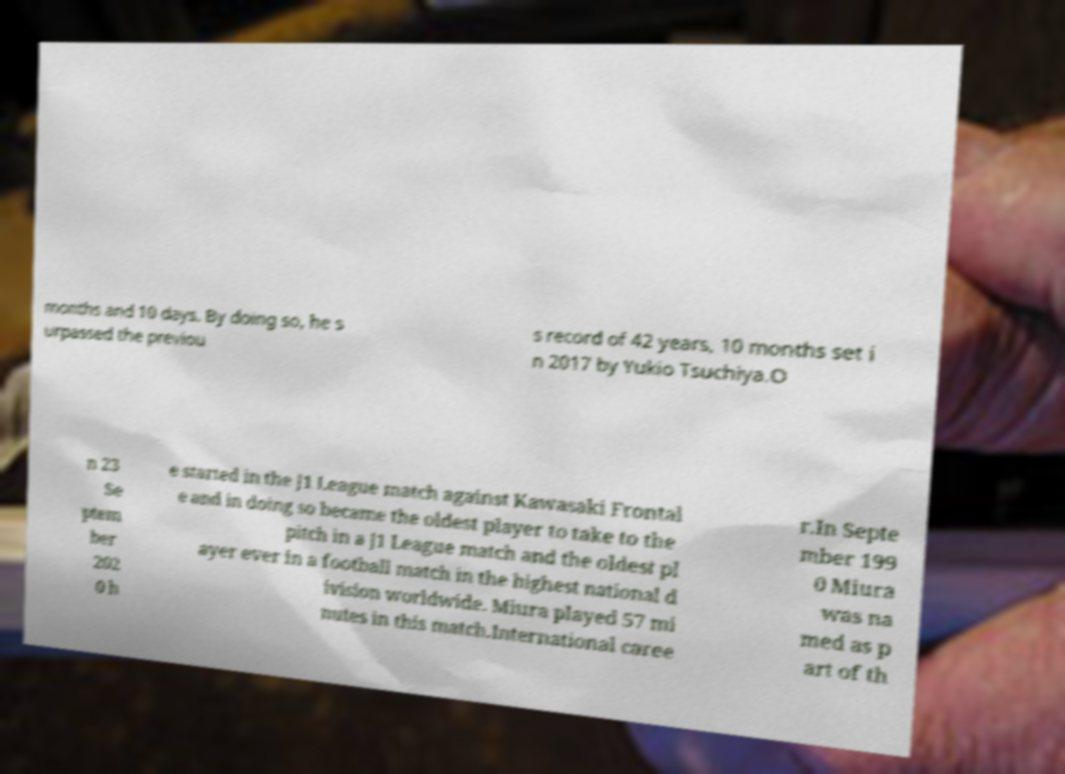For documentation purposes, I need the text within this image transcribed. Could you provide that? months and 10 days. By doing so, he s urpassed the previou s record of 42 years, 10 months set i n 2017 by Yukio Tsuchiya.O n 23 Se ptem ber 202 0 h e started in the J1 League match against Kawasaki Frontal e and in doing so became the oldest player to take to the pitch in a J1 League match and the oldest pl ayer ever in a football match in the highest national d ivision worldwide. Miura played 57 mi nutes in this match.International caree r.In Septe mber 199 0 Miura was na med as p art of th 